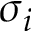Convert formula to latex. <formula><loc_0><loc_0><loc_500><loc_500>\sigma _ { i }</formula> 